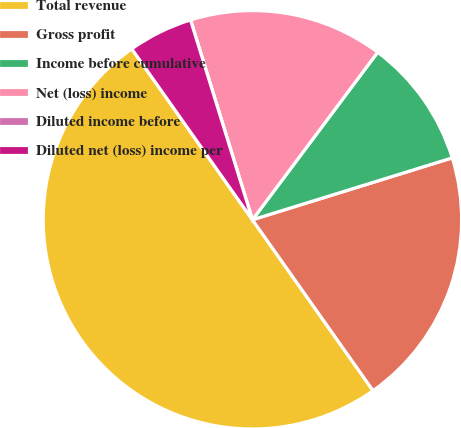Convert chart to OTSL. <chart><loc_0><loc_0><loc_500><loc_500><pie_chart><fcel>Total revenue<fcel>Gross profit<fcel>Income before cumulative<fcel>Net (loss) income<fcel>Diluted income before<fcel>Diluted net (loss) income per<nl><fcel>50.0%<fcel>20.0%<fcel>10.0%<fcel>15.0%<fcel>0.0%<fcel>5.0%<nl></chart> 